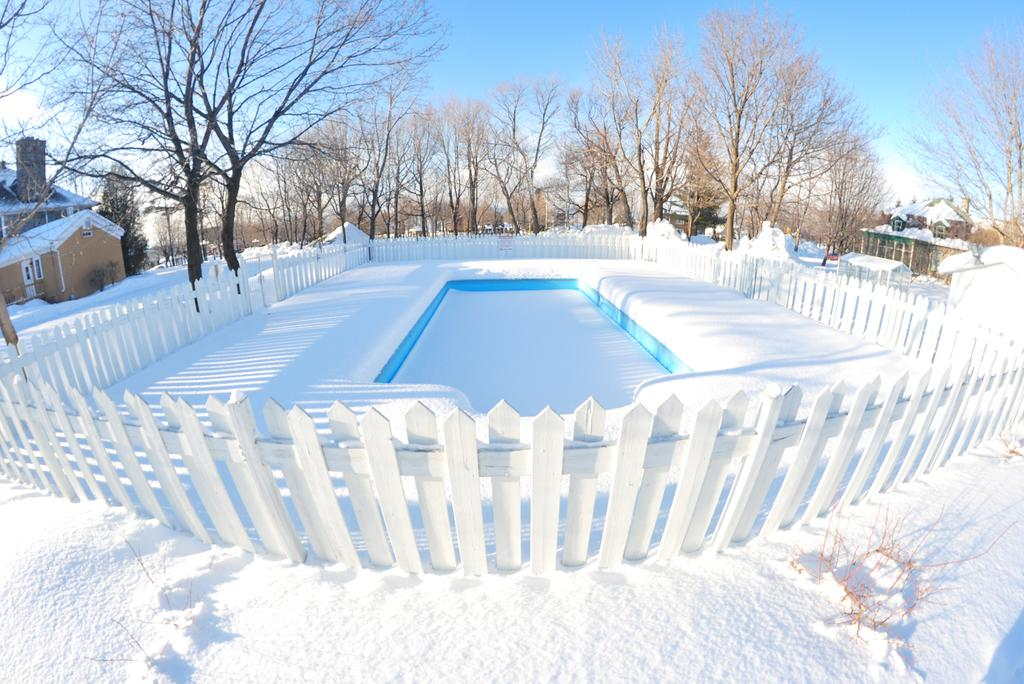What is the main subject of the image? The main subject of the image is an ice. What type of structure can be seen in the image? There is fencing in the image. What type of natural environment is visible in the image? There are trees in the image. What type of building is present in the image? There is a house in the image. What is the weather like in the image? There is snow in the image, indicating a cold or wintry environment. What is visible in the sky in the image? The sky is visible in the image. Can you see a volcano erupting in the image? No, there is no volcano present in the image. Is there a bike leaning against the house in the image? No, there is no bike present in the image. 